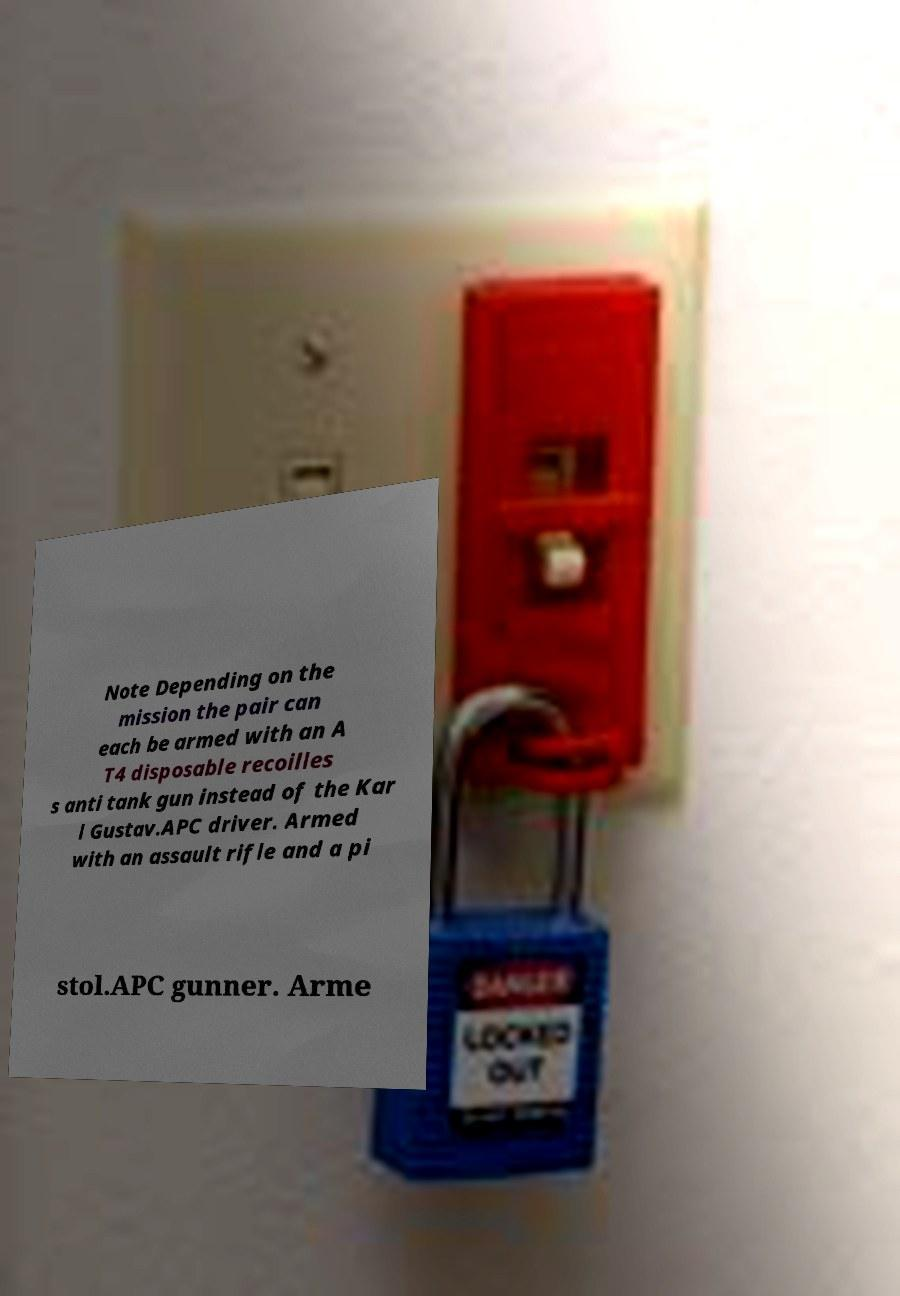Please read and relay the text visible in this image. What does it say? Note Depending on the mission the pair can each be armed with an A T4 disposable recoilles s anti tank gun instead of the Kar l Gustav.APC driver. Armed with an assault rifle and a pi stol.APC gunner. Arme 